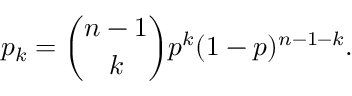Convert formula to latex. <formula><loc_0><loc_0><loc_500><loc_500>p _ { k } = { \binom { n - 1 } { k } } p ^ { k } ( 1 - p ) ^ { n - 1 - k } .</formula> 